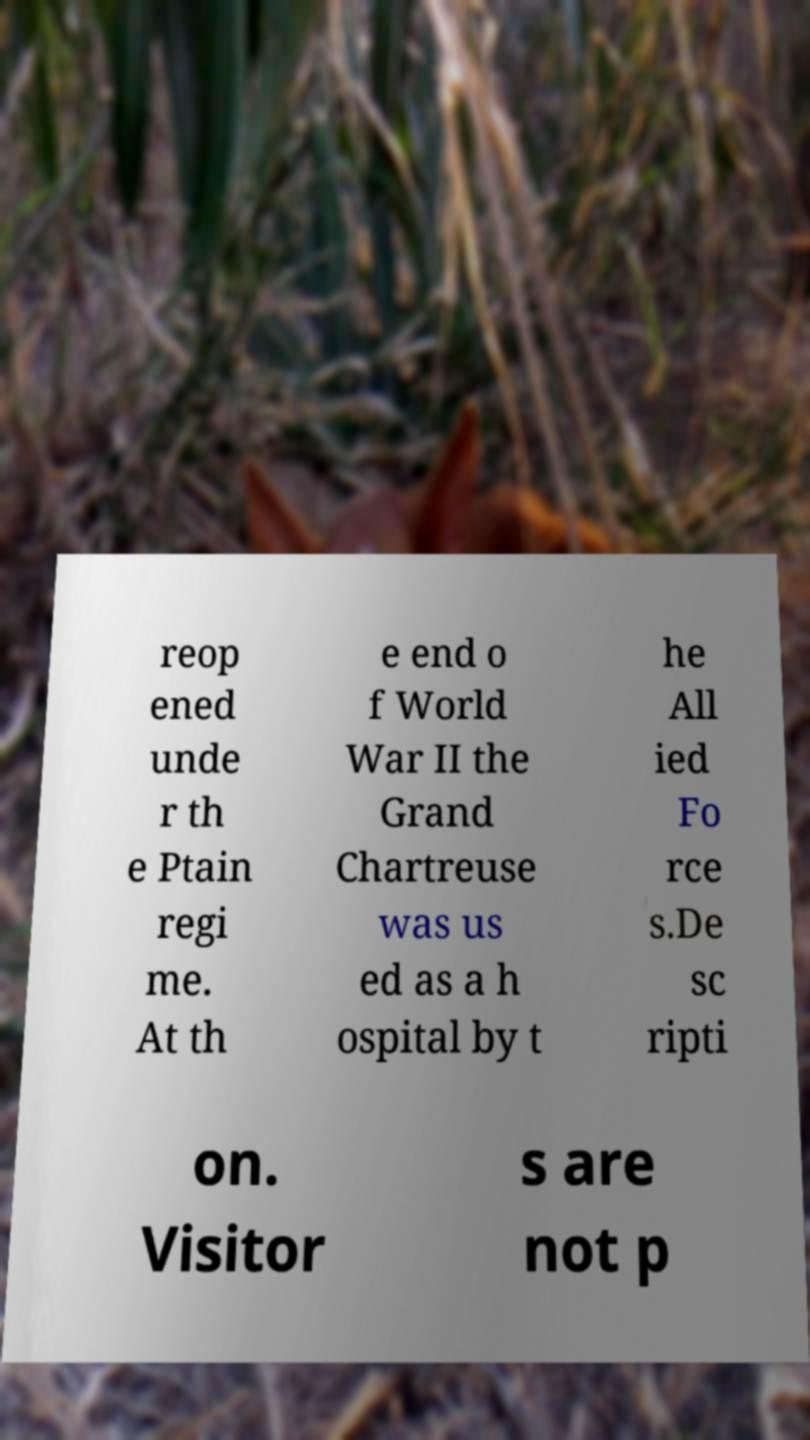Could you extract and type out the text from this image? reop ened unde r th e Ptain regi me. At th e end o f World War II the Grand Chartreuse was us ed as a h ospital by t he All ied Fo rce s.De sc ripti on. Visitor s are not p 